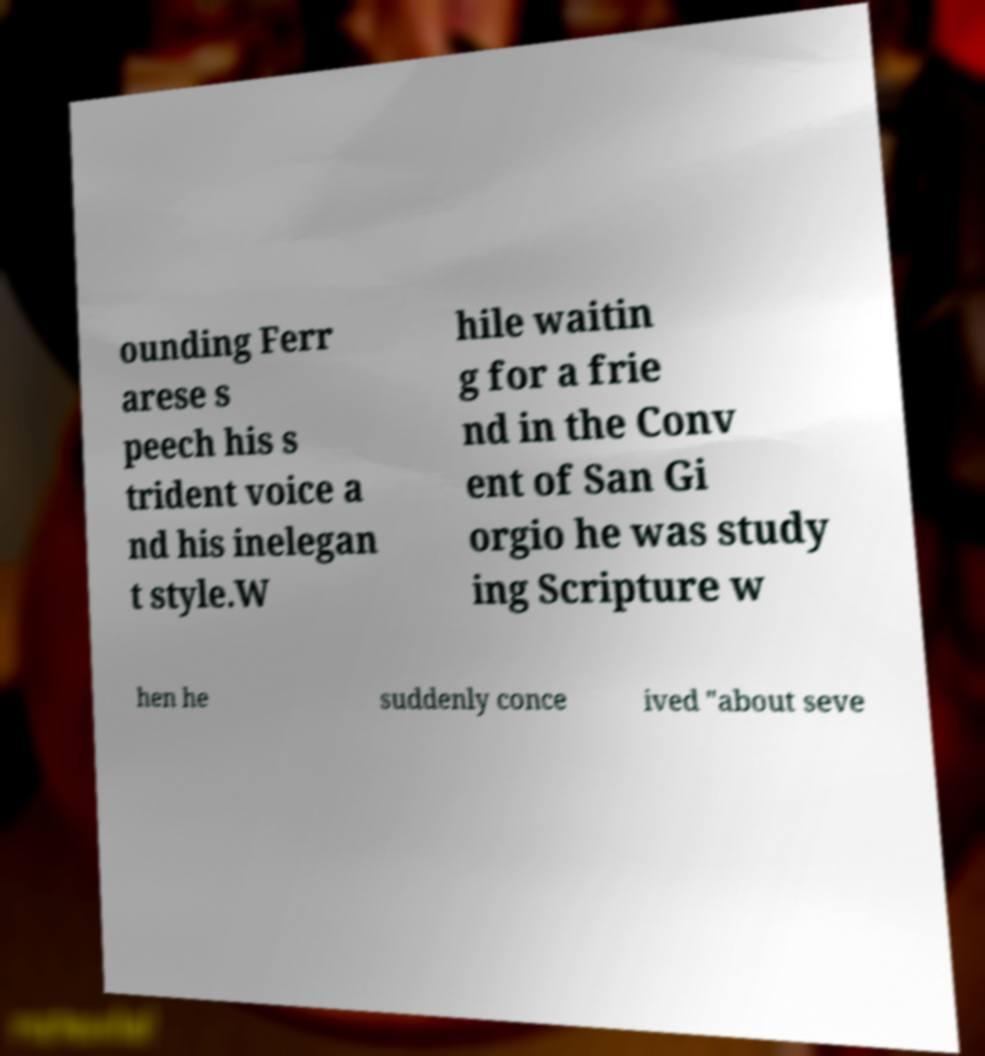Could you assist in decoding the text presented in this image and type it out clearly? ounding Ferr arese s peech his s trident voice a nd his inelegan t style.W hile waitin g for a frie nd in the Conv ent of San Gi orgio he was study ing Scripture w hen he suddenly conce ived "about seve 